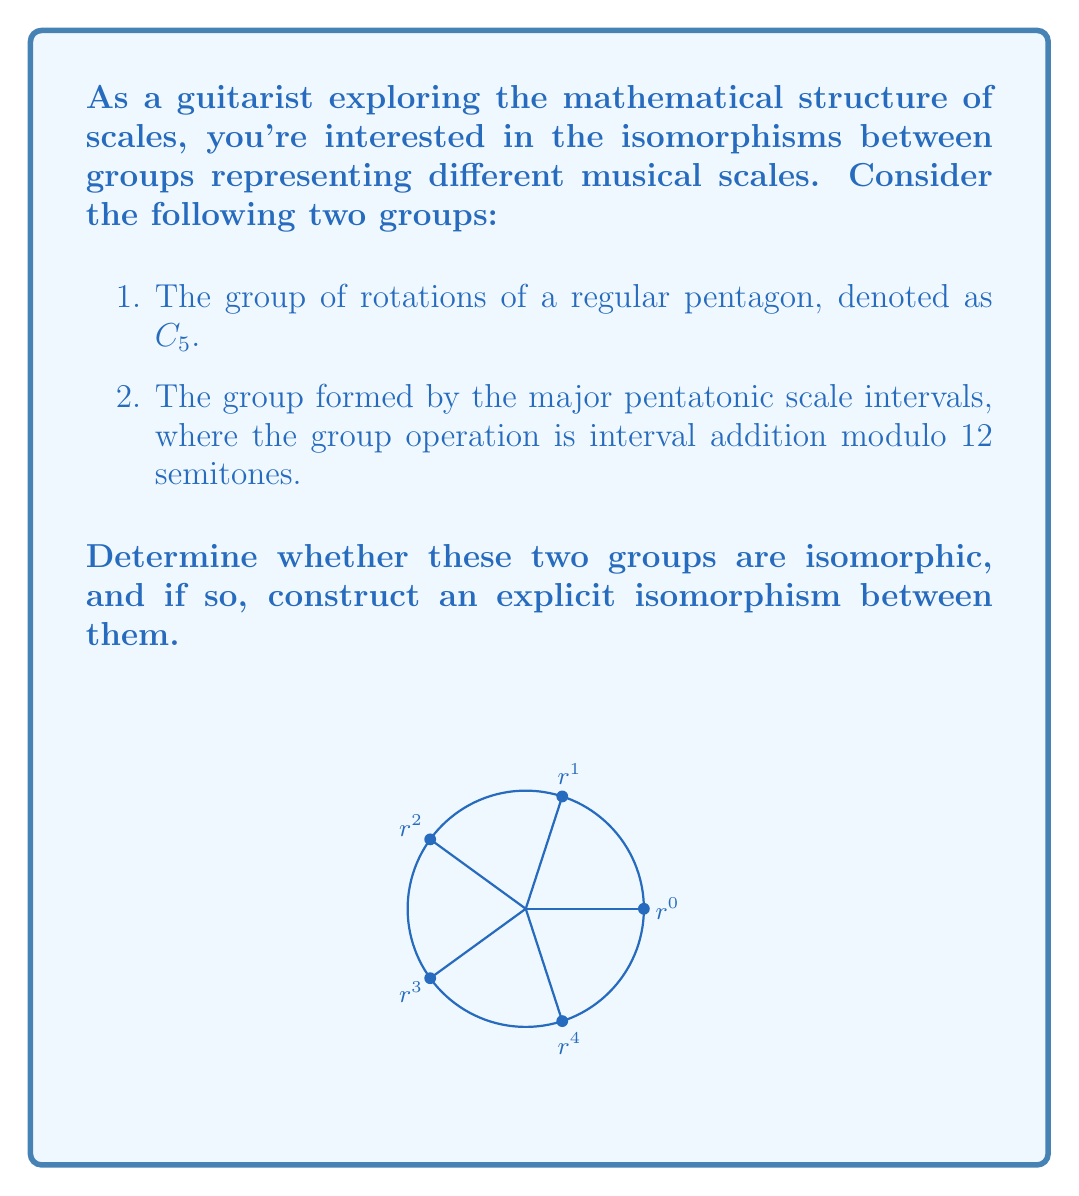Can you solve this math problem? To determine if the two groups are isomorphic, we need to:
1. Identify the elements and structure of both groups
2. Check if they have the same order and cyclic structure
3. Construct an isomorphism if possible

Step 1: Identify the groups

a) The group $C_5$ (rotations of a pentagon):
   Elements: $\{e, r, r^2, r^3, r^4\}$, where $e$ is the identity and $r$ is a rotation by 72°
   Order: 5

b) The major pentatonic scale intervals group:
   Elements: $\{0, 2, 4, 7, 9\}$ (semitones above the root)
   Operation: Addition modulo 12
   Order: 5

Step 2: Check order and cyclic structure

Both groups have order 5 and are cyclic. This suggests they might be isomorphic.

Step 3: Construct an isomorphism

Let's define a mapping $\phi$ from $C_5$ to the pentatonic scale group:

$\phi(e) = 0$
$\phi(r) = 2$
$\phi(r^2) = 4$
$\phi(r^3) = 7$
$\phi(r^4) = 9$

To prove this is an isomorphism, we need to show it's bijective and preserves the group operation:

1. Bijective: Each element in $C_5$ maps to a unique element in the pentatonic group, and every element in the pentatonic group is mapped to.

2. Preserves operation: For any $a, b \in C_5$,
   $\phi(ab) = \phi(a) + \phi(b) \pmod{12}$

For example:
$\phi(r \cdot r^2) = \phi(r^3) = 7$
$\phi(r) + \phi(r^2) = 2 + 4 = 6 \equiv 7 \pmod{12}$

This holds for all combinations, proving $\phi$ is an isomorphism.
Answer: Yes, isomorphic. $\phi(r^n) = 2n \pmod{12}$ for $n = 0, 1, 2, 3, 4$. 